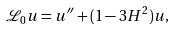<formula> <loc_0><loc_0><loc_500><loc_500>\mathcal { L } _ { 0 } u = u ^ { \prime \prime } + ( 1 - 3 H ^ { 2 } ) u ,</formula> 